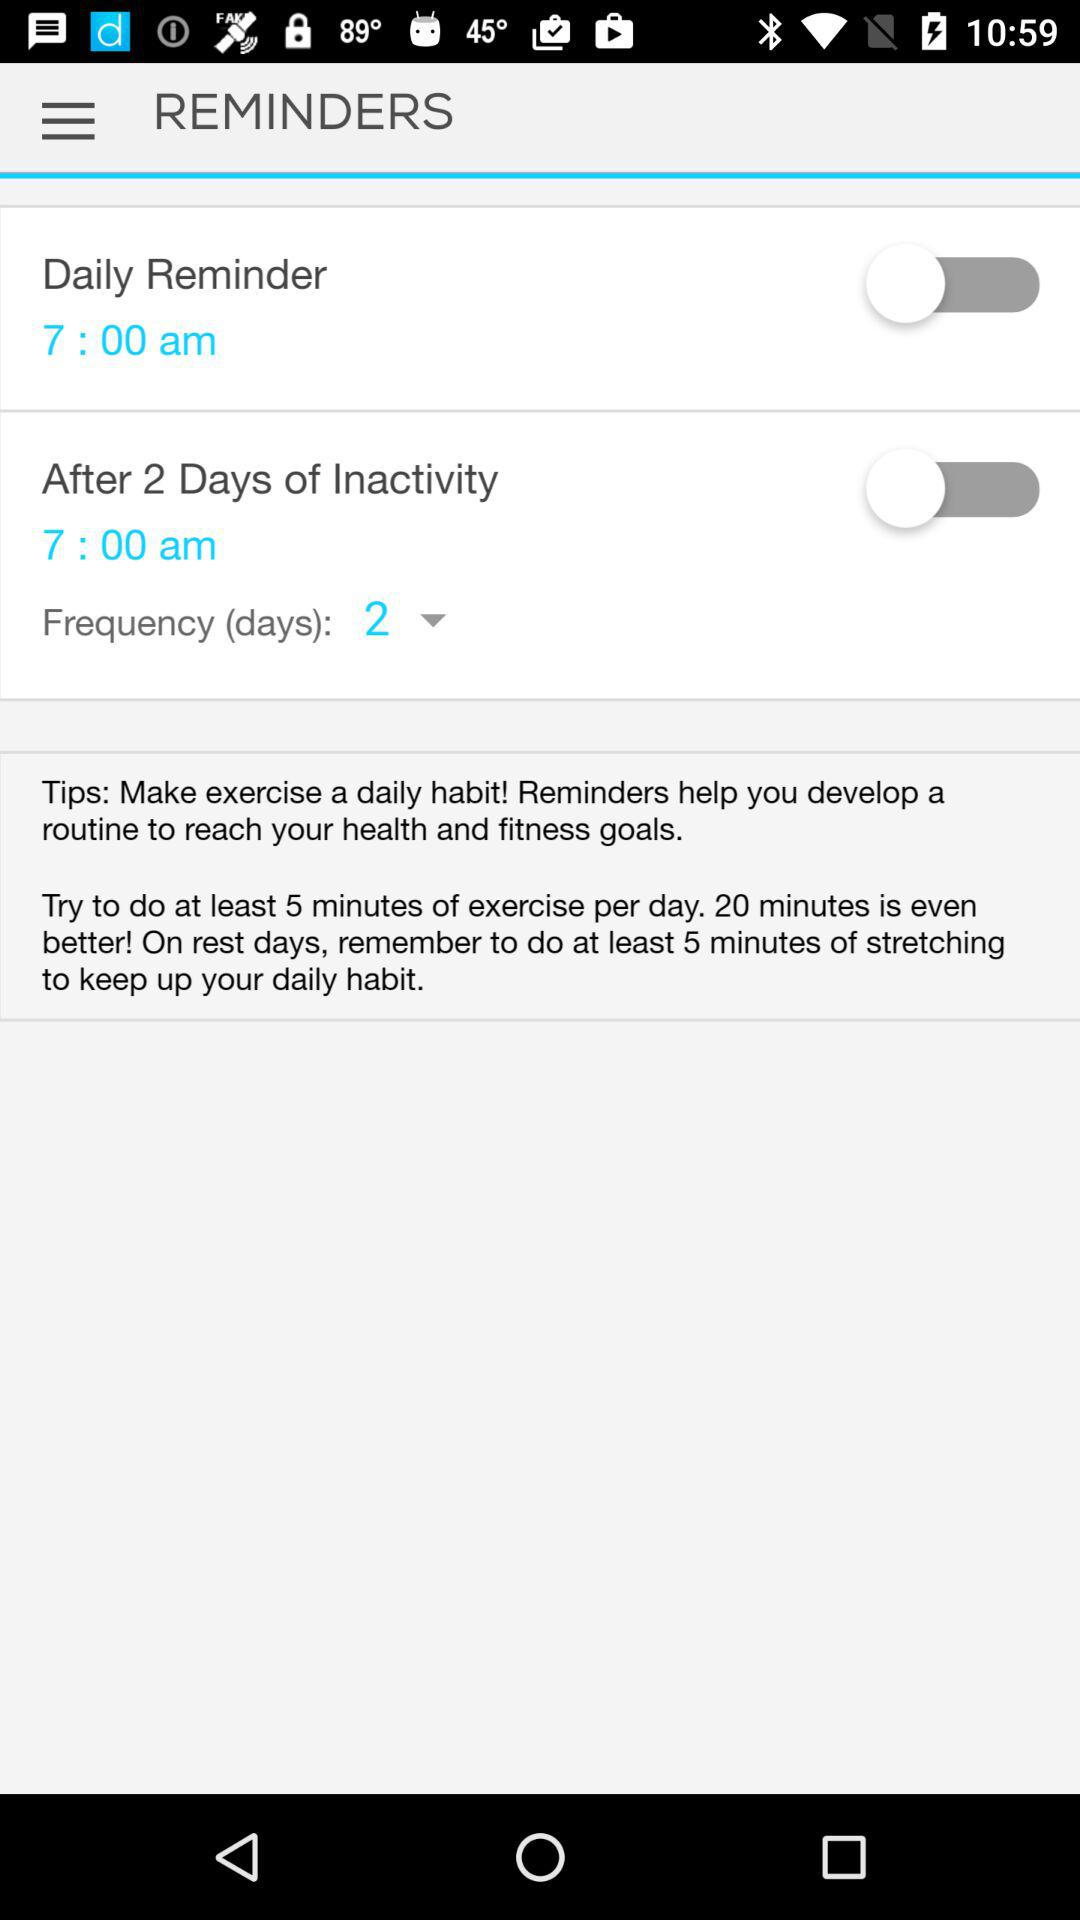Is the switch for "After 2 Days of Inactivity" on or off? The switch for "After 2 Days of Inactivity" is off. 